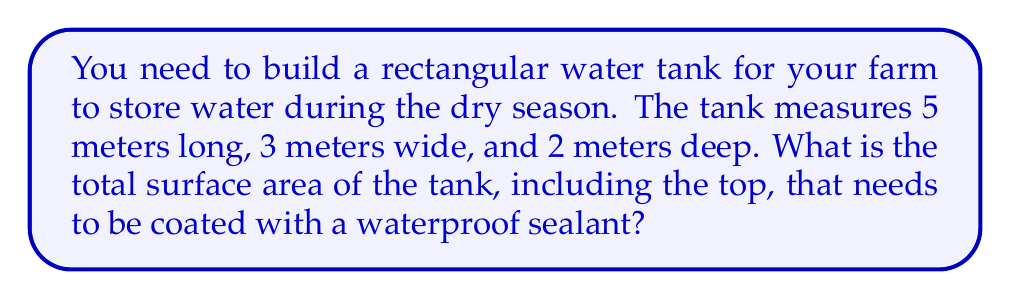Help me with this question. Let's approach this step-by-step:

1) First, let's identify the dimensions of the tank:
   Length (l) = 5 m
   Width (w) = 3 m
   Height (h) = 2 m

2) A rectangular tank has 6 faces: top, bottom, front, back, and two sides.

3) The area of each face:
   - Top and bottom: $A_{tb} = l \times w = 5 \times 3 = 15$ m²
   - Front and back: $A_{fb} = l \times h = 5 \times 2 = 10$ m²
   - Two sides: $A_s = w \times h = 3 \times 2 = 6$ m²

4) To get the total surface area, we sum up all these faces:
   $$\text{Total Surface Area} = 2A_{tb} + 2A_{fb} + 2A_s$$

5) Substituting the values:
   $$\text{Total Surface Area} = 2(15) + 2(10) + 2(6)$$
   $$= 30 + 20 + 12$$
   $$= 62\text{ m}^2$$

Therefore, the total surface area of the tank that needs to be coated is 62 square meters.
Answer: 62 m² 